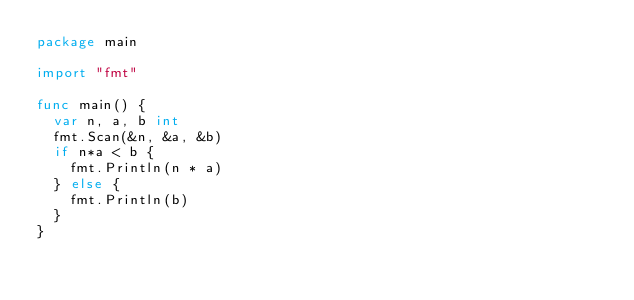<code> <loc_0><loc_0><loc_500><loc_500><_Go_>package main

import "fmt"

func main() {
	var n, a, b int
	fmt.Scan(&n, &a, &b)
	if n*a < b {
		fmt.Println(n * a)
	} else {
		fmt.Println(b)
	}
}
</code> 